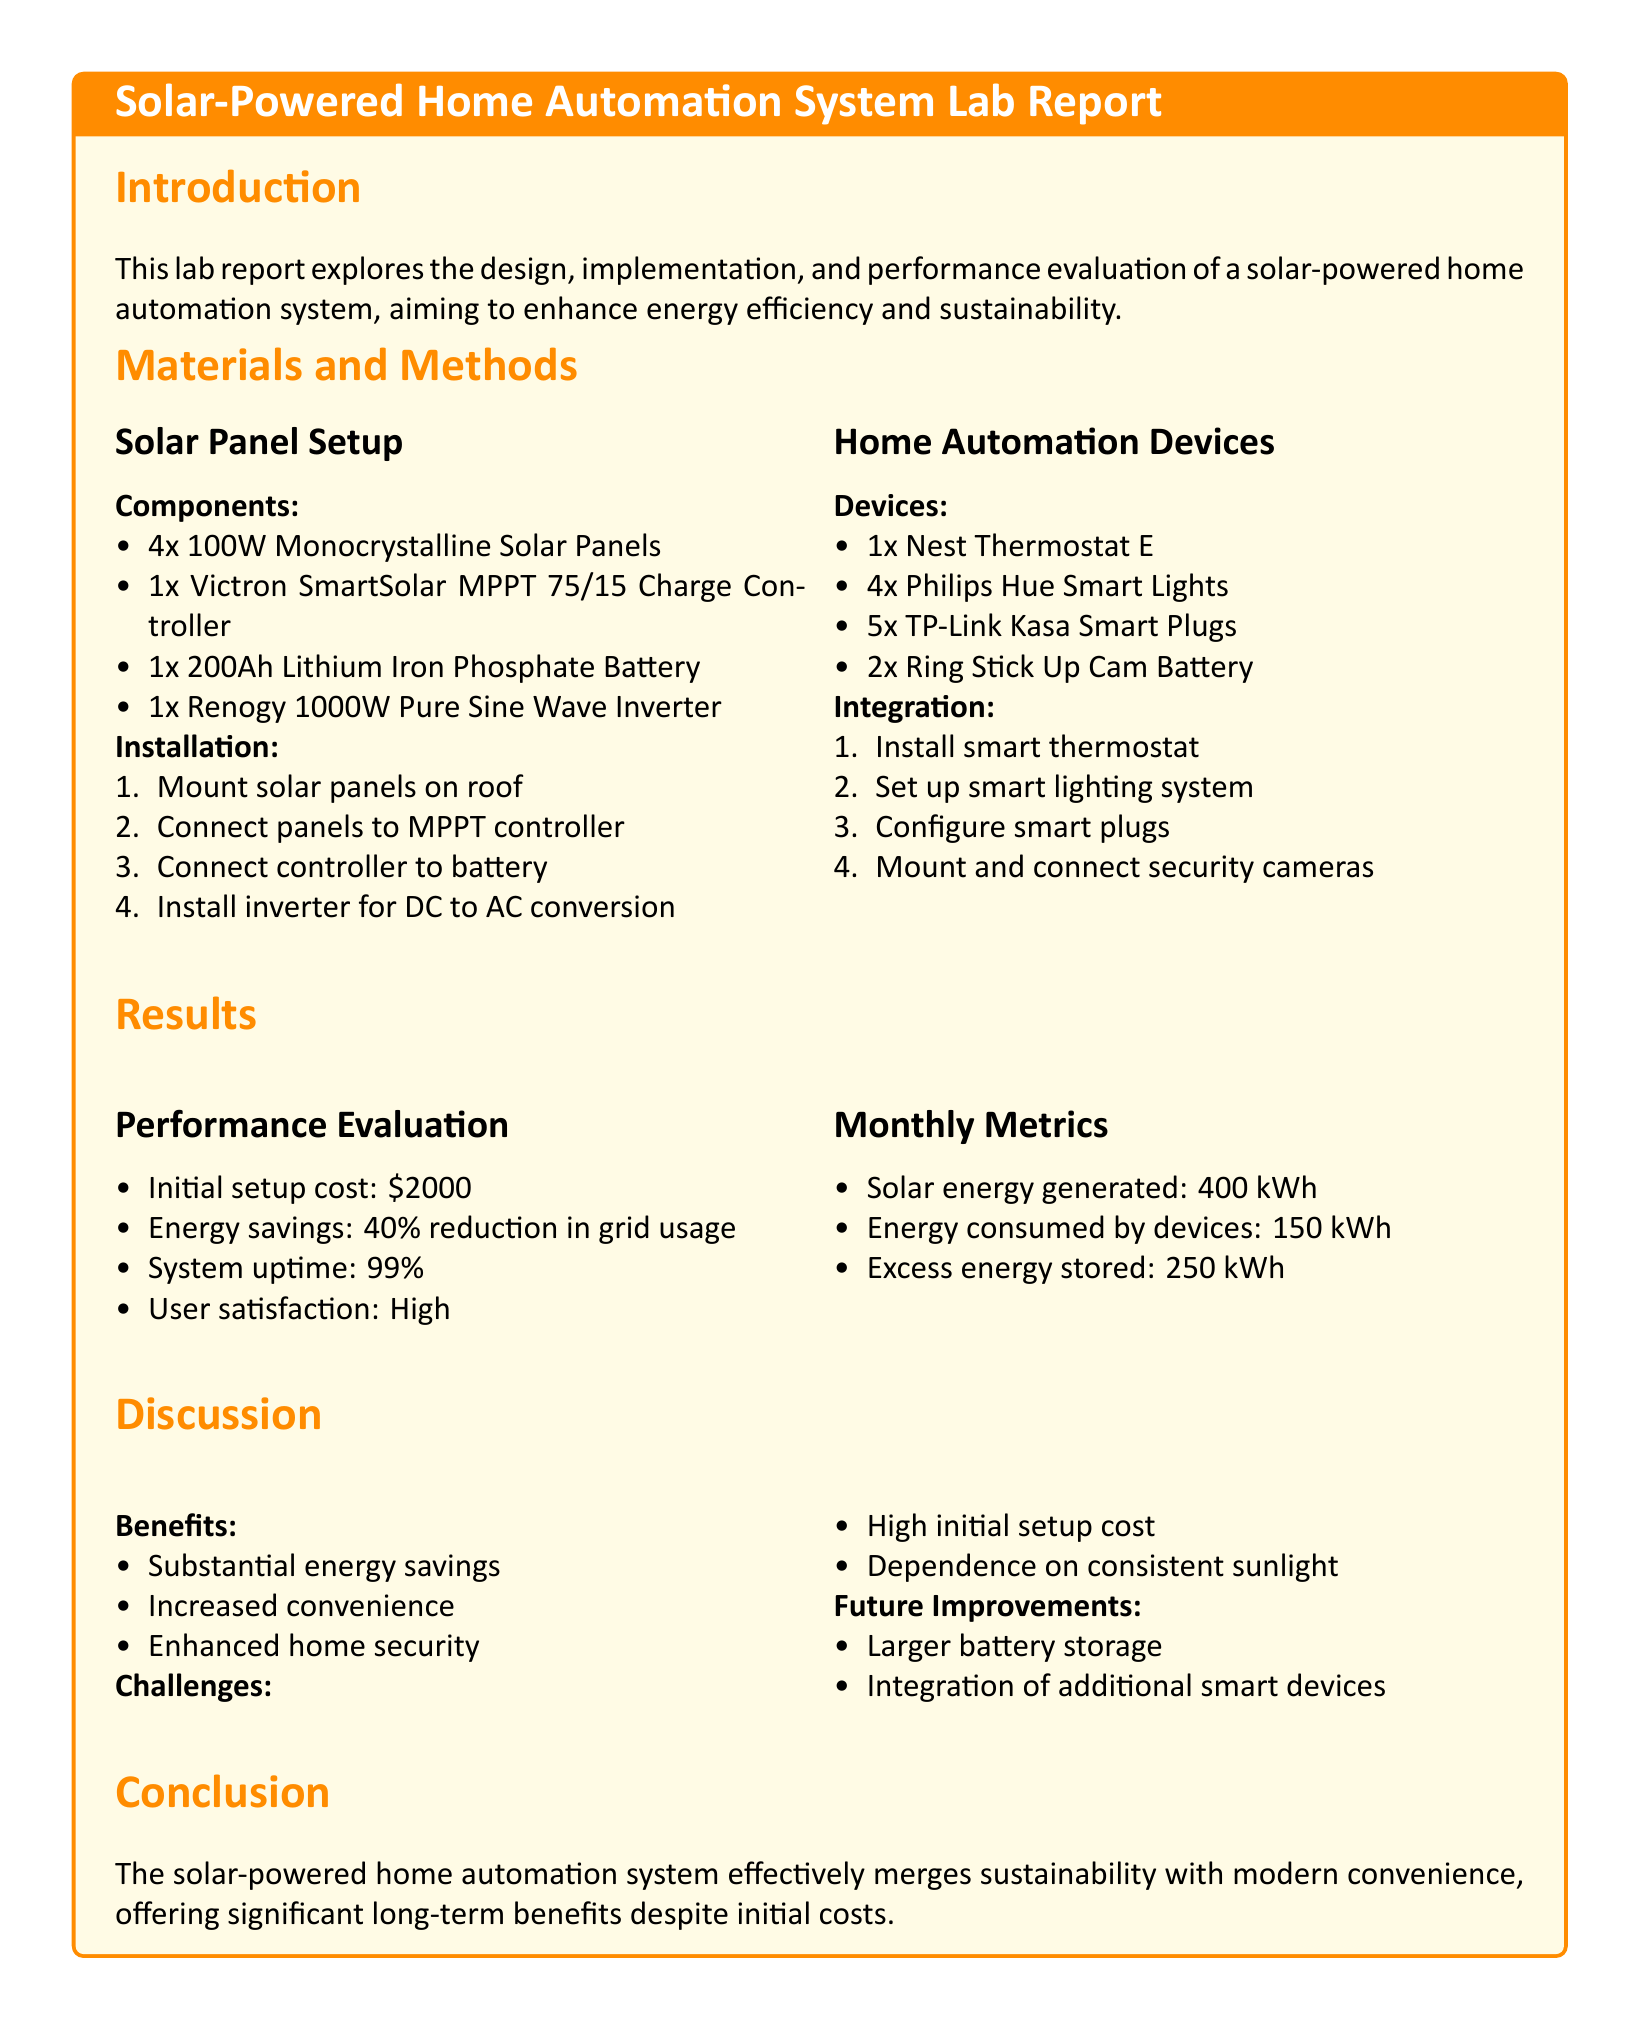What is the initial setup cost? The initial setup cost is listed in the results section of the document as $2000.
Answer: $2000 How much solar energy was generated monthly? The solar energy generated is mentioned in the monthly metrics section as 400 kWh.
Answer: 400 kWh What type of battery is used in the system? The battery used is specified as a Lithium Iron Phosphate Battery in the materials and methods section.
Answer: Lithium Iron Phosphate Battery What percentage of grid usage reduction was achieved? The percentage reduction in grid usage is stated in the performance evaluation as 40%.
Answer: 40% What is the system uptime percentage? The system uptime percentage is provided in the performance evaluation section as 99%.
Answer: 99% What is one benefit of the solar-powered home automation system? One benefit mentioned in the discussion is substantial energy savings.
Answer: Substantial energy savings What challenge is mentioned regarding sunlight? The document discusses the dependence on consistent sunlight as a challenge in the discussion section.
Answer: Dependence on consistent sunlight What feature does the document suggest for future improvements? The document suggests larger battery storage as a future improvement in the discussion section.
Answer: Larger battery storage What is one smart device used in this system? The smart devices listed include the Nest Thermostat E, which is found in the home automation devices section.
Answer: Nest Thermostat E 